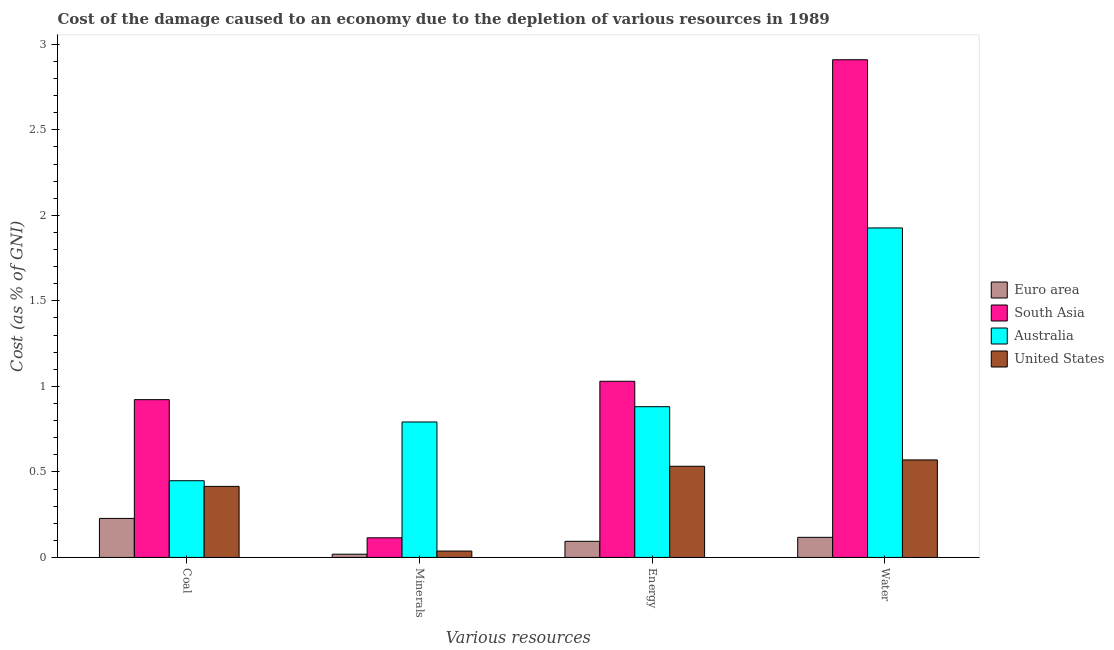How many groups of bars are there?
Offer a terse response. 4. Are the number of bars per tick equal to the number of legend labels?
Make the answer very short. Yes. Are the number of bars on each tick of the X-axis equal?
Make the answer very short. Yes. How many bars are there on the 1st tick from the left?
Make the answer very short. 4. How many bars are there on the 1st tick from the right?
Make the answer very short. 4. What is the label of the 3rd group of bars from the left?
Provide a short and direct response. Energy. What is the cost of damage due to depletion of minerals in Australia?
Make the answer very short. 0.79. Across all countries, what is the maximum cost of damage due to depletion of minerals?
Your answer should be very brief. 0.79. Across all countries, what is the minimum cost of damage due to depletion of water?
Keep it short and to the point. 0.12. In which country was the cost of damage due to depletion of minerals maximum?
Your response must be concise. Australia. What is the total cost of damage due to depletion of coal in the graph?
Provide a succinct answer. 2.01. What is the difference between the cost of damage due to depletion of energy in Euro area and that in Australia?
Make the answer very short. -0.79. What is the difference between the cost of damage due to depletion of water in United States and the cost of damage due to depletion of minerals in Euro area?
Provide a succinct answer. 0.55. What is the average cost of damage due to depletion of coal per country?
Make the answer very short. 0.5. What is the difference between the cost of damage due to depletion of energy and cost of damage due to depletion of coal in Australia?
Give a very brief answer. 0.43. What is the ratio of the cost of damage due to depletion of energy in Euro area to that in Australia?
Provide a short and direct response. 0.11. What is the difference between the highest and the second highest cost of damage due to depletion of energy?
Give a very brief answer. 0.15. What is the difference between the highest and the lowest cost of damage due to depletion of coal?
Offer a very short reply. 0.69. In how many countries, is the cost of damage due to depletion of water greater than the average cost of damage due to depletion of water taken over all countries?
Offer a very short reply. 2. Is it the case that in every country, the sum of the cost of damage due to depletion of water and cost of damage due to depletion of coal is greater than the sum of cost of damage due to depletion of energy and cost of damage due to depletion of minerals?
Provide a succinct answer. No. What does the 2nd bar from the left in Minerals represents?
Offer a terse response. South Asia. What does the 3rd bar from the right in Water represents?
Provide a succinct answer. South Asia. Is it the case that in every country, the sum of the cost of damage due to depletion of coal and cost of damage due to depletion of minerals is greater than the cost of damage due to depletion of energy?
Offer a terse response. No. How many bars are there?
Ensure brevity in your answer.  16. Are all the bars in the graph horizontal?
Make the answer very short. No. How many countries are there in the graph?
Provide a short and direct response. 4. Does the graph contain any zero values?
Make the answer very short. No. Does the graph contain grids?
Your answer should be compact. No. How many legend labels are there?
Provide a succinct answer. 4. What is the title of the graph?
Provide a short and direct response. Cost of the damage caused to an economy due to the depletion of various resources in 1989 . What is the label or title of the X-axis?
Give a very brief answer. Various resources. What is the label or title of the Y-axis?
Make the answer very short. Cost (as % of GNI). What is the Cost (as % of GNI) in Euro area in Coal?
Ensure brevity in your answer.  0.23. What is the Cost (as % of GNI) of South Asia in Coal?
Provide a short and direct response. 0.92. What is the Cost (as % of GNI) in Australia in Coal?
Offer a terse response. 0.45. What is the Cost (as % of GNI) in United States in Coal?
Provide a short and direct response. 0.42. What is the Cost (as % of GNI) of Euro area in Minerals?
Ensure brevity in your answer.  0.02. What is the Cost (as % of GNI) in South Asia in Minerals?
Provide a succinct answer. 0.11. What is the Cost (as % of GNI) in Australia in Minerals?
Offer a terse response. 0.79. What is the Cost (as % of GNI) in United States in Minerals?
Provide a succinct answer. 0.04. What is the Cost (as % of GNI) in Euro area in Energy?
Ensure brevity in your answer.  0.09. What is the Cost (as % of GNI) in South Asia in Energy?
Keep it short and to the point. 1.03. What is the Cost (as % of GNI) in Australia in Energy?
Give a very brief answer. 0.88. What is the Cost (as % of GNI) of United States in Energy?
Give a very brief answer. 0.53. What is the Cost (as % of GNI) in Euro area in Water?
Provide a succinct answer. 0.12. What is the Cost (as % of GNI) in South Asia in Water?
Offer a terse response. 2.91. What is the Cost (as % of GNI) of Australia in Water?
Make the answer very short. 1.93. What is the Cost (as % of GNI) of United States in Water?
Give a very brief answer. 0.57. Across all Various resources, what is the maximum Cost (as % of GNI) of Euro area?
Provide a short and direct response. 0.23. Across all Various resources, what is the maximum Cost (as % of GNI) in South Asia?
Your answer should be very brief. 2.91. Across all Various resources, what is the maximum Cost (as % of GNI) of Australia?
Keep it short and to the point. 1.93. Across all Various resources, what is the maximum Cost (as % of GNI) of United States?
Provide a succinct answer. 0.57. Across all Various resources, what is the minimum Cost (as % of GNI) in Euro area?
Provide a short and direct response. 0.02. Across all Various resources, what is the minimum Cost (as % of GNI) of South Asia?
Provide a succinct answer. 0.11. Across all Various resources, what is the minimum Cost (as % of GNI) in Australia?
Make the answer very short. 0.45. Across all Various resources, what is the minimum Cost (as % of GNI) in United States?
Ensure brevity in your answer.  0.04. What is the total Cost (as % of GNI) in Euro area in the graph?
Give a very brief answer. 0.46. What is the total Cost (as % of GNI) of South Asia in the graph?
Your answer should be very brief. 4.98. What is the total Cost (as % of GNI) in Australia in the graph?
Keep it short and to the point. 4.05. What is the total Cost (as % of GNI) in United States in the graph?
Keep it short and to the point. 1.56. What is the difference between the Cost (as % of GNI) of Euro area in Coal and that in Minerals?
Your response must be concise. 0.21. What is the difference between the Cost (as % of GNI) of South Asia in Coal and that in Minerals?
Your response must be concise. 0.81. What is the difference between the Cost (as % of GNI) of Australia in Coal and that in Minerals?
Your answer should be very brief. -0.34. What is the difference between the Cost (as % of GNI) in United States in Coal and that in Minerals?
Keep it short and to the point. 0.38. What is the difference between the Cost (as % of GNI) in Euro area in Coal and that in Energy?
Offer a terse response. 0.13. What is the difference between the Cost (as % of GNI) in South Asia in Coal and that in Energy?
Give a very brief answer. -0.11. What is the difference between the Cost (as % of GNI) of Australia in Coal and that in Energy?
Keep it short and to the point. -0.43. What is the difference between the Cost (as % of GNI) of United States in Coal and that in Energy?
Keep it short and to the point. -0.12. What is the difference between the Cost (as % of GNI) in Euro area in Coal and that in Water?
Your response must be concise. 0.11. What is the difference between the Cost (as % of GNI) in South Asia in Coal and that in Water?
Ensure brevity in your answer.  -1.99. What is the difference between the Cost (as % of GNI) of Australia in Coal and that in Water?
Provide a succinct answer. -1.48. What is the difference between the Cost (as % of GNI) of United States in Coal and that in Water?
Give a very brief answer. -0.15. What is the difference between the Cost (as % of GNI) of Euro area in Minerals and that in Energy?
Your answer should be very brief. -0.08. What is the difference between the Cost (as % of GNI) of South Asia in Minerals and that in Energy?
Ensure brevity in your answer.  -0.92. What is the difference between the Cost (as % of GNI) in Australia in Minerals and that in Energy?
Ensure brevity in your answer.  -0.09. What is the difference between the Cost (as % of GNI) of United States in Minerals and that in Energy?
Provide a succinct answer. -0.5. What is the difference between the Cost (as % of GNI) in Euro area in Minerals and that in Water?
Provide a succinct answer. -0.1. What is the difference between the Cost (as % of GNI) of South Asia in Minerals and that in Water?
Provide a short and direct response. -2.8. What is the difference between the Cost (as % of GNI) of Australia in Minerals and that in Water?
Provide a succinct answer. -1.13. What is the difference between the Cost (as % of GNI) in United States in Minerals and that in Water?
Your answer should be very brief. -0.53. What is the difference between the Cost (as % of GNI) of Euro area in Energy and that in Water?
Offer a very short reply. -0.02. What is the difference between the Cost (as % of GNI) in South Asia in Energy and that in Water?
Your answer should be compact. -1.88. What is the difference between the Cost (as % of GNI) in Australia in Energy and that in Water?
Keep it short and to the point. -1.05. What is the difference between the Cost (as % of GNI) in United States in Energy and that in Water?
Provide a short and direct response. -0.04. What is the difference between the Cost (as % of GNI) of Euro area in Coal and the Cost (as % of GNI) of South Asia in Minerals?
Give a very brief answer. 0.11. What is the difference between the Cost (as % of GNI) in Euro area in Coal and the Cost (as % of GNI) in Australia in Minerals?
Offer a terse response. -0.56. What is the difference between the Cost (as % of GNI) in Euro area in Coal and the Cost (as % of GNI) in United States in Minerals?
Offer a terse response. 0.19. What is the difference between the Cost (as % of GNI) of South Asia in Coal and the Cost (as % of GNI) of Australia in Minerals?
Give a very brief answer. 0.13. What is the difference between the Cost (as % of GNI) of South Asia in Coal and the Cost (as % of GNI) of United States in Minerals?
Provide a short and direct response. 0.89. What is the difference between the Cost (as % of GNI) in Australia in Coal and the Cost (as % of GNI) in United States in Minerals?
Provide a short and direct response. 0.41. What is the difference between the Cost (as % of GNI) in Euro area in Coal and the Cost (as % of GNI) in South Asia in Energy?
Your answer should be compact. -0.8. What is the difference between the Cost (as % of GNI) of Euro area in Coal and the Cost (as % of GNI) of Australia in Energy?
Give a very brief answer. -0.65. What is the difference between the Cost (as % of GNI) in Euro area in Coal and the Cost (as % of GNI) in United States in Energy?
Keep it short and to the point. -0.3. What is the difference between the Cost (as % of GNI) in South Asia in Coal and the Cost (as % of GNI) in Australia in Energy?
Give a very brief answer. 0.04. What is the difference between the Cost (as % of GNI) of South Asia in Coal and the Cost (as % of GNI) of United States in Energy?
Your answer should be compact. 0.39. What is the difference between the Cost (as % of GNI) in Australia in Coal and the Cost (as % of GNI) in United States in Energy?
Provide a short and direct response. -0.08. What is the difference between the Cost (as % of GNI) of Euro area in Coal and the Cost (as % of GNI) of South Asia in Water?
Make the answer very short. -2.68. What is the difference between the Cost (as % of GNI) in Euro area in Coal and the Cost (as % of GNI) in Australia in Water?
Ensure brevity in your answer.  -1.7. What is the difference between the Cost (as % of GNI) in Euro area in Coal and the Cost (as % of GNI) in United States in Water?
Offer a very short reply. -0.34. What is the difference between the Cost (as % of GNI) of South Asia in Coal and the Cost (as % of GNI) of Australia in Water?
Keep it short and to the point. -1. What is the difference between the Cost (as % of GNI) of South Asia in Coal and the Cost (as % of GNI) of United States in Water?
Provide a short and direct response. 0.35. What is the difference between the Cost (as % of GNI) in Australia in Coal and the Cost (as % of GNI) in United States in Water?
Provide a succinct answer. -0.12. What is the difference between the Cost (as % of GNI) in Euro area in Minerals and the Cost (as % of GNI) in South Asia in Energy?
Make the answer very short. -1.01. What is the difference between the Cost (as % of GNI) of Euro area in Minerals and the Cost (as % of GNI) of Australia in Energy?
Ensure brevity in your answer.  -0.86. What is the difference between the Cost (as % of GNI) of Euro area in Minerals and the Cost (as % of GNI) of United States in Energy?
Provide a succinct answer. -0.51. What is the difference between the Cost (as % of GNI) in South Asia in Minerals and the Cost (as % of GNI) in Australia in Energy?
Offer a very short reply. -0.77. What is the difference between the Cost (as % of GNI) in South Asia in Minerals and the Cost (as % of GNI) in United States in Energy?
Ensure brevity in your answer.  -0.42. What is the difference between the Cost (as % of GNI) of Australia in Minerals and the Cost (as % of GNI) of United States in Energy?
Your answer should be compact. 0.26. What is the difference between the Cost (as % of GNI) in Euro area in Minerals and the Cost (as % of GNI) in South Asia in Water?
Make the answer very short. -2.89. What is the difference between the Cost (as % of GNI) in Euro area in Minerals and the Cost (as % of GNI) in Australia in Water?
Ensure brevity in your answer.  -1.91. What is the difference between the Cost (as % of GNI) in Euro area in Minerals and the Cost (as % of GNI) in United States in Water?
Your response must be concise. -0.55. What is the difference between the Cost (as % of GNI) of South Asia in Minerals and the Cost (as % of GNI) of Australia in Water?
Make the answer very short. -1.81. What is the difference between the Cost (as % of GNI) in South Asia in Minerals and the Cost (as % of GNI) in United States in Water?
Offer a terse response. -0.46. What is the difference between the Cost (as % of GNI) in Australia in Minerals and the Cost (as % of GNI) in United States in Water?
Your response must be concise. 0.22. What is the difference between the Cost (as % of GNI) in Euro area in Energy and the Cost (as % of GNI) in South Asia in Water?
Keep it short and to the point. -2.82. What is the difference between the Cost (as % of GNI) of Euro area in Energy and the Cost (as % of GNI) of Australia in Water?
Provide a short and direct response. -1.83. What is the difference between the Cost (as % of GNI) in Euro area in Energy and the Cost (as % of GNI) in United States in Water?
Your answer should be very brief. -0.48. What is the difference between the Cost (as % of GNI) in South Asia in Energy and the Cost (as % of GNI) in Australia in Water?
Provide a short and direct response. -0.9. What is the difference between the Cost (as % of GNI) of South Asia in Energy and the Cost (as % of GNI) of United States in Water?
Keep it short and to the point. 0.46. What is the difference between the Cost (as % of GNI) in Australia in Energy and the Cost (as % of GNI) in United States in Water?
Keep it short and to the point. 0.31. What is the average Cost (as % of GNI) of Euro area per Various resources?
Give a very brief answer. 0.11. What is the average Cost (as % of GNI) in South Asia per Various resources?
Offer a terse response. 1.24. What is the average Cost (as % of GNI) in Australia per Various resources?
Ensure brevity in your answer.  1.01. What is the average Cost (as % of GNI) of United States per Various resources?
Provide a short and direct response. 0.39. What is the difference between the Cost (as % of GNI) in Euro area and Cost (as % of GNI) in South Asia in Coal?
Make the answer very short. -0.69. What is the difference between the Cost (as % of GNI) in Euro area and Cost (as % of GNI) in Australia in Coal?
Your response must be concise. -0.22. What is the difference between the Cost (as % of GNI) of Euro area and Cost (as % of GNI) of United States in Coal?
Offer a very short reply. -0.19. What is the difference between the Cost (as % of GNI) in South Asia and Cost (as % of GNI) in Australia in Coal?
Give a very brief answer. 0.47. What is the difference between the Cost (as % of GNI) in South Asia and Cost (as % of GNI) in United States in Coal?
Keep it short and to the point. 0.51. What is the difference between the Cost (as % of GNI) in Australia and Cost (as % of GNI) in United States in Coal?
Make the answer very short. 0.03. What is the difference between the Cost (as % of GNI) of Euro area and Cost (as % of GNI) of South Asia in Minerals?
Provide a short and direct response. -0.1. What is the difference between the Cost (as % of GNI) in Euro area and Cost (as % of GNI) in Australia in Minerals?
Give a very brief answer. -0.77. What is the difference between the Cost (as % of GNI) in Euro area and Cost (as % of GNI) in United States in Minerals?
Make the answer very short. -0.02. What is the difference between the Cost (as % of GNI) in South Asia and Cost (as % of GNI) in Australia in Minerals?
Keep it short and to the point. -0.68. What is the difference between the Cost (as % of GNI) in South Asia and Cost (as % of GNI) in United States in Minerals?
Keep it short and to the point. 0.08. What is the difference between the Cost (as % of GNI) of Australia and Cost (as % of GNI) of United States in Minerals?
Offer a very short reply. 0.75. What is the difference between the Cost (as % of GNI) in Euro area and Cost (as % of GNI) in South Asia in Energy?
Offer a terse response. -0.94. What is the difference between the Cost (as % of GNI) in Euro area and Cost (as % of GNI) in Australia in Energy?
Provide a short and direct response. -0.79. What is the difference between the Cost (as % of GNI) of Euro area and Cost (as % of GNI) of United States in Energy?
Offer a terse response. -0.44. What is the difference between the Cost (as % of GNI) of South Asia and Cost (as % of GNI) of Australia in Energy?
Your answer should be very brief. 0.15. What is the difference between the Cost (as % of GNI) in South Asia and Cost (as % of GNI) in United States in Energy?
Offer a terse response. 0.5. What is the difference between the Cost (as % of GNI) in Australia and Cost (as % of GNI) in United States in Energy?
Your answer should be compact. 0.35. What is the difference between the Cost (as % of GNI) in Euro area and Cost (as % of GNI) in South Asia in Water?
Your response must be concise. -2.79. What is the difference between the Cost (as % of GNI) in Euro area and Cost (as % of GNI) in Australia in Water?
Provide a succinct answer. -1.81. What is the difference between the Cost (as % of GNI) of Euro area and Cost (as % of GNI) of United States in Water?
Provide a succinct answer. -0.45. What is the difference between the Cost (as % of GNI) of South Asia and Cost (as % of GNI) of Australia in Water?
Make the answer very short. 0.98. What is the difference between the Cost (as % of GNI) in South Asia and Cost (as % of GNI) in United States in Water?
Provide a short and direct response. 2.34. What is the difference between the Cost (as % of GNI) in Australia and Cost (as % of GNI) in United States in Water?
Provide a succinct answer. 1.36. What is the ratio of the Cost (as % of GNI) of Euro area in Coal to that in Minerals?
Keep it short and to the point. 12.09. What is the ratio of the Cost (as % of GNI) of South Asia in Coal to that in Minerals?
Your answer should be very brief. 8.04. What is the ratio of the Cost (as % of GNI) of Australia in Coal to that in Minerals?
Make the answer very short. 0.57. What is the ratio of the Cost (as % of GNI) of United States in Coal to that in Minerals?
Your response must be concise. 11.18. What is the ratio of the Cost (as % of GNI) in Euro area in Coal to that in Energy?
Keep it short and to the point. 2.42. What is the ratio of the Cost (as % of GNI) in South Asia in Coal to that in Energy?
Your response must be concise. 0.9. What is the ratio of the Cost (as % of GNI) of Australia in Coal to that in Energy?
Make the answer very short. 0.51. What is the ratio of the Cost (as % of GNI) of United States in Coal to that in Energy?
Your response must be concise. 0.78. What is the ratio of the Cost (as % of GNI) of Euro area in Coal to that in Water?
Ensure brevity in your answer.  1.94. What is the ratio of the Cost (as % of GNI) in South Asia in Coal to that in Water?
Keep it short and to the point. 0.32. What is the ratio of the Cost (as % of GNI) in Australia in Coal to that in Water?
Keep it short and to the point. 0.23. What is the ratio of the Cost (as % of GNI) in United States in Coal to that in Water?
Your answer should be compact. 0.73. What is the ratio of the Cost (as % of GNI) of Euro area in Minerals to that in Energy?
Ensure brevity in your answer.  0.2. What is the ratio of the Cost (as % of GNI) of South Asia in Minerals to that in Energy?
Provide a short and direct response. 0.11. What is the ratio of the Cost (as % of GNI) of Australia in Minerals to that in Energy?
Provide a succinct answer. 0.9. What is the ratio of the Cost (as % of GNI) of United States in Minerals to that in Energy?
Make the answer very short. 0.07. What is the ratio of the Cost (as % of GNI) of Euro area in Minerals to that in Water?
Keep it short and to the point. 0.16. What is the ratio of the Cost (as % of GNI) in South Asia in Minerals to that in Water?
Offer a terse response. 0.04. What is the ratio of the Cost (as % of GNI) in Australia in Minerals to that in Water?
Your answer should be compact. 0.41. What is the ratio of the Cost (as % of GNI) of United States in Minerals to that in Water?
Keep it short and to the point. 0.07. What is the ratio of the Cost (as % of GNI) of Euro area in Energy to that in Water?
Give a very brief answer. 0.8. What is the ratio of the Cost (as % of GNI) in South Asia in Energy to that in Water?
Make the answer very short. 0.35. What is the ratio of the Cost (as % of GNI) in Australia in Energy to that in Water?
Your answer should be compact. 0.46. What is the ratio of the Cost (as % of GNI) in United States in Energy to that in Water?
Your response must be concise. 0.93. What is the difference between the highest and the second highest Cost (as % of GNI) in Euro area?
Provide a short and direct response. 0.11. What is the difference between the highest and the second highest Cost (as % of GNI) of South Asia?
Keep it short and to the point. 1.88. What is the difference between the highest and the second highest Cost (as % of GNI) of Australia?
Your response must be concise. 1.05. What is the difference between the highest and the second highest Cost (as % of GNI) of United States?
Offer a very short reply. 0.04. What is the difference between the highest and the lowest Cost (as % of GNI) in Euro area?
Your answer should be compact. 0.21. What is the difference between the highest and the lowest Cost (as % of GNI) in South Asia?
Offer a terse response. 2.8. What is the difference between the highest and the lowest Cost (as % of GNI) of Australia?
Make the answer very short. 1.48. What is the difference between the highest and the lowest Cost (as % of GNI) of United States?
Provide a short and direct response. 0.53. 